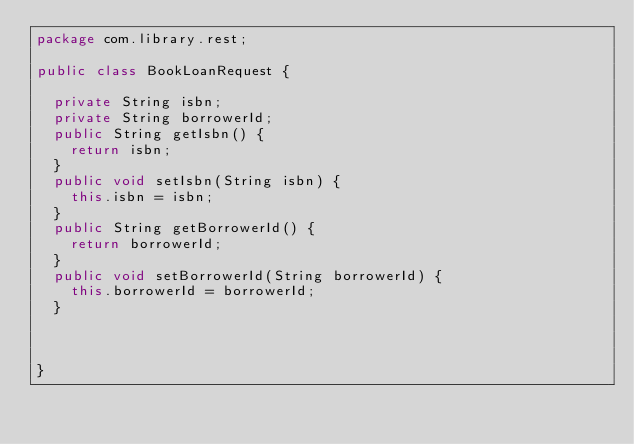Convert code to text. <code><loc_0><loc_0><loc_500><loc_500><_Java_>package com.library.rest;

public class BookLoanRequest {

	private String isbn;
	private String borrowerId;
	public String getIsbn() {
		return isbn;
	}
	public void setIsbn(String isbn) {
		this.isbn = isbn;
	}
	public String getBorrowerId() {
		return borrowerId;
	}
	public void setBorrowerId(String borrowerId) {
		this.borrowerId = borrowerId;
	}
	
	
	
}
</code> 